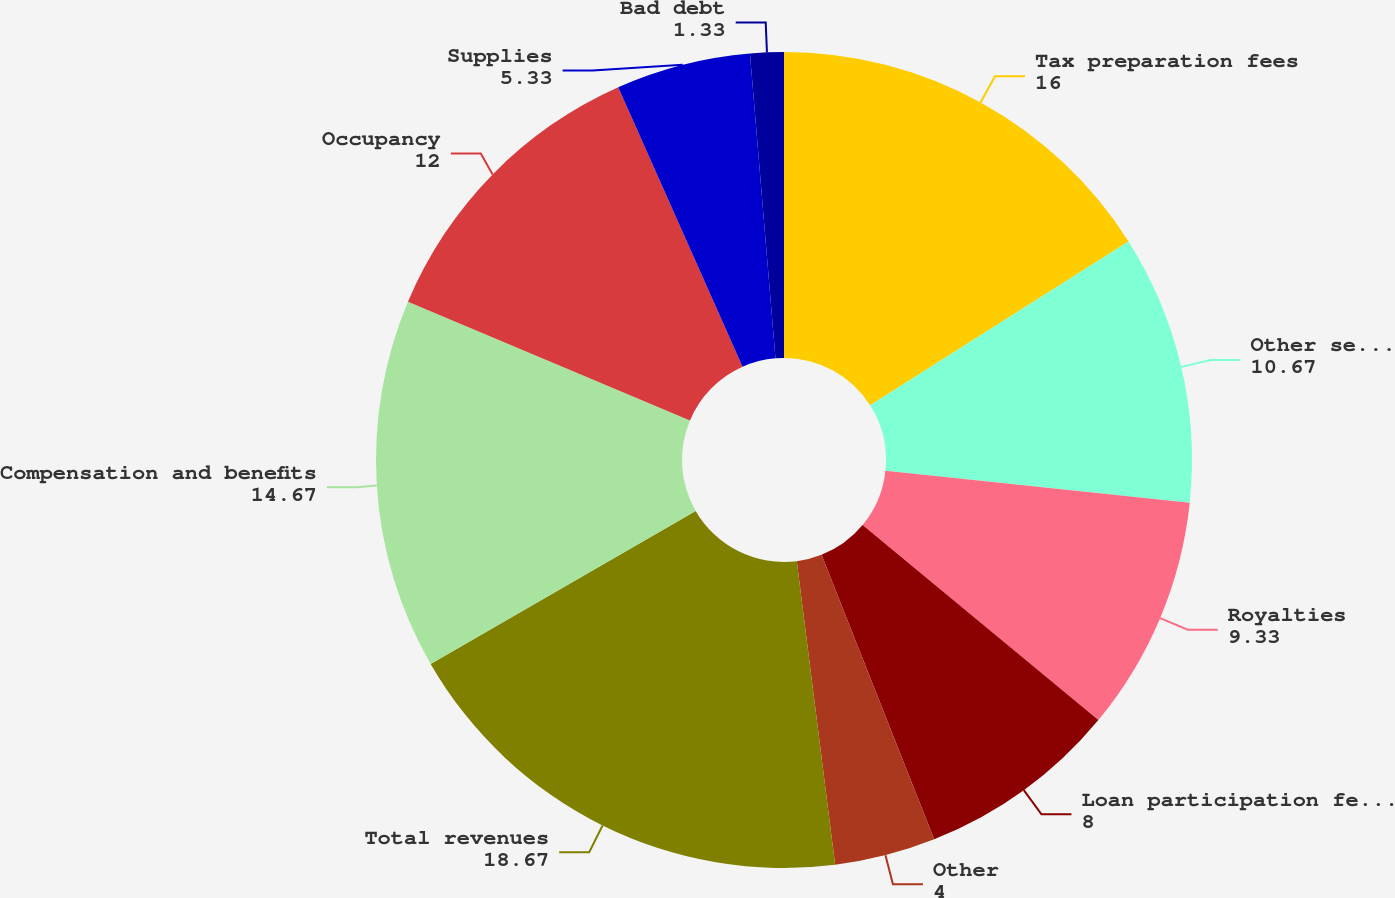<chart> <loc_0><loc_0><loc_500><loc_500><pie_chart><fcel>Tax preparation fees<fcel>Other services<fcel>Royalties<fcel>Loan participation fees and<fcel>Other<fcel>Total revenues<fcel>Compensation and benefits<fcel>Occupancy<fcel>Supplies<fcel>Bad debt<nl><fcel>16.0%<fcel>10.67%<fcel>9.33%<fcel>8.0%<fcel>4.0%<fcel>18.67%<fcel>14.67%<fcel>12.0%<fcel>5.33%<fcel>1.33%<nl></chart> 